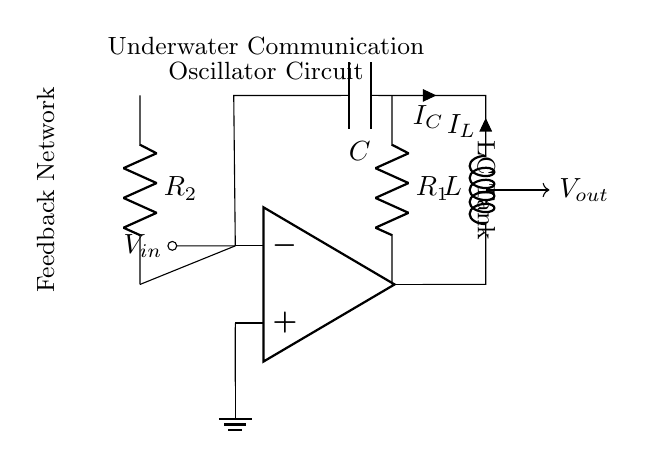What is the function of the inductor in this circuit? The inductor in this LC tank oscillator circuit stores energy in the magnetic field and helps determine the oscillation frequency in conjunction with the capacitor.
Answer: energy storage What component comes after the amplifier output? After the amplifier output, the first component is the inductor, which is denoted as L in the circuit diagram.
Answer: inductor What does the feedback network consist of? The feedback network consists of two resistors labeled R1 and R2, which provide feedback to the inverting input of the operational amplifier.
Answer: two resistors What is the primary purpose of this oscillator circuit? The primary purpose of this oscillator circuit is to generate signals for underwater communication devices during diving training.
Answer: communication signals How many main reactive components are present in the LC tank? There are two main reactive components present in the LC tank: one inductor and one capacitor.
Answer: two What is the relationship between current and reactive components in this circuit? In this LC tank oscillator, the current flowing through the inductor and capacitor oscillates back and forth, creating alternating current due to their energy exchange.
Answer: oscillates What type of oscillator is represented by this circuit? This circuit represents an LC tank oscillator, characterized by the resonant frequency determined by the inductor and capacitor.
Answer: LC tank oscillator 